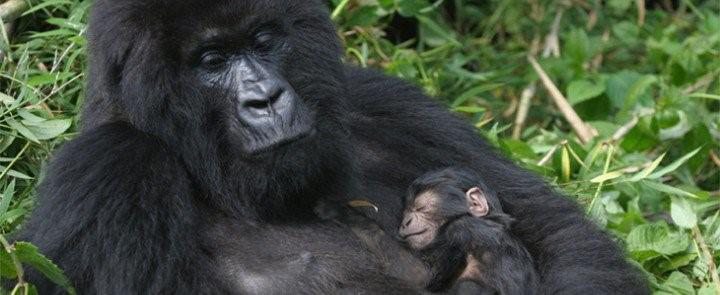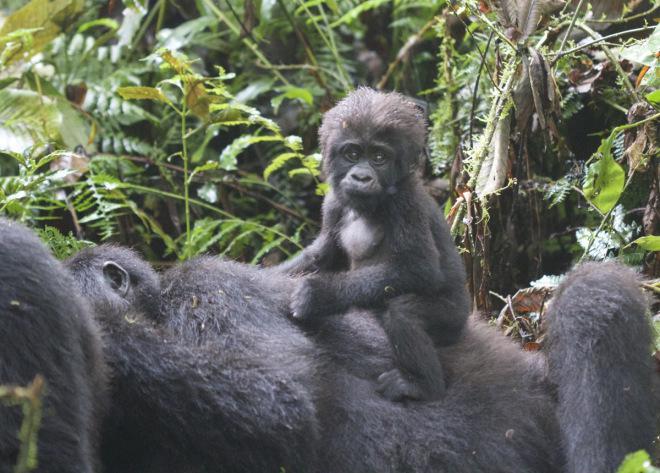The first image is the image on the left, the second image is the image on the right. For the images displayed, is the sentence "Atleast 3 animals in every picture." factually correct? Answer yes or no. No. The first image is the image on the left, the second image is the image on the right. Assess this claim about the two images: "The image on the right shows at least one baby gorilla atop an adult gorilla that is not facing the camera.". Correct or not? Answer yes or no. Yes. 